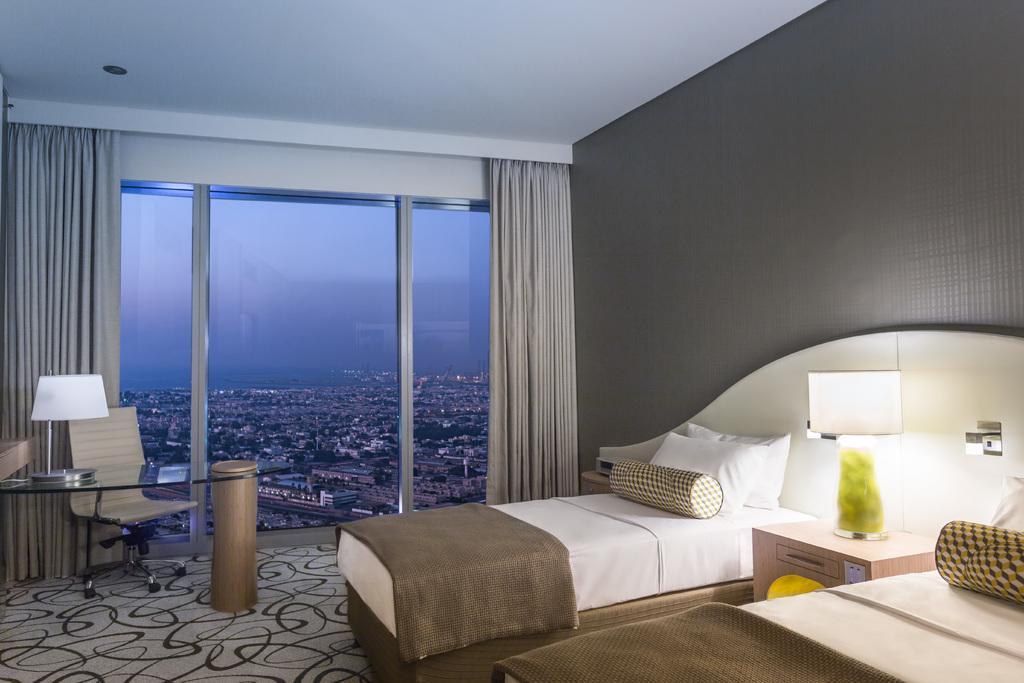Could you give a brief overview of what you see in this image? In this picture we can see two beds with bed sheets and pillows on it, tables, lamps, chair on the floor, glass, curtains, wall and from the glass we can see buildings and the sky. 